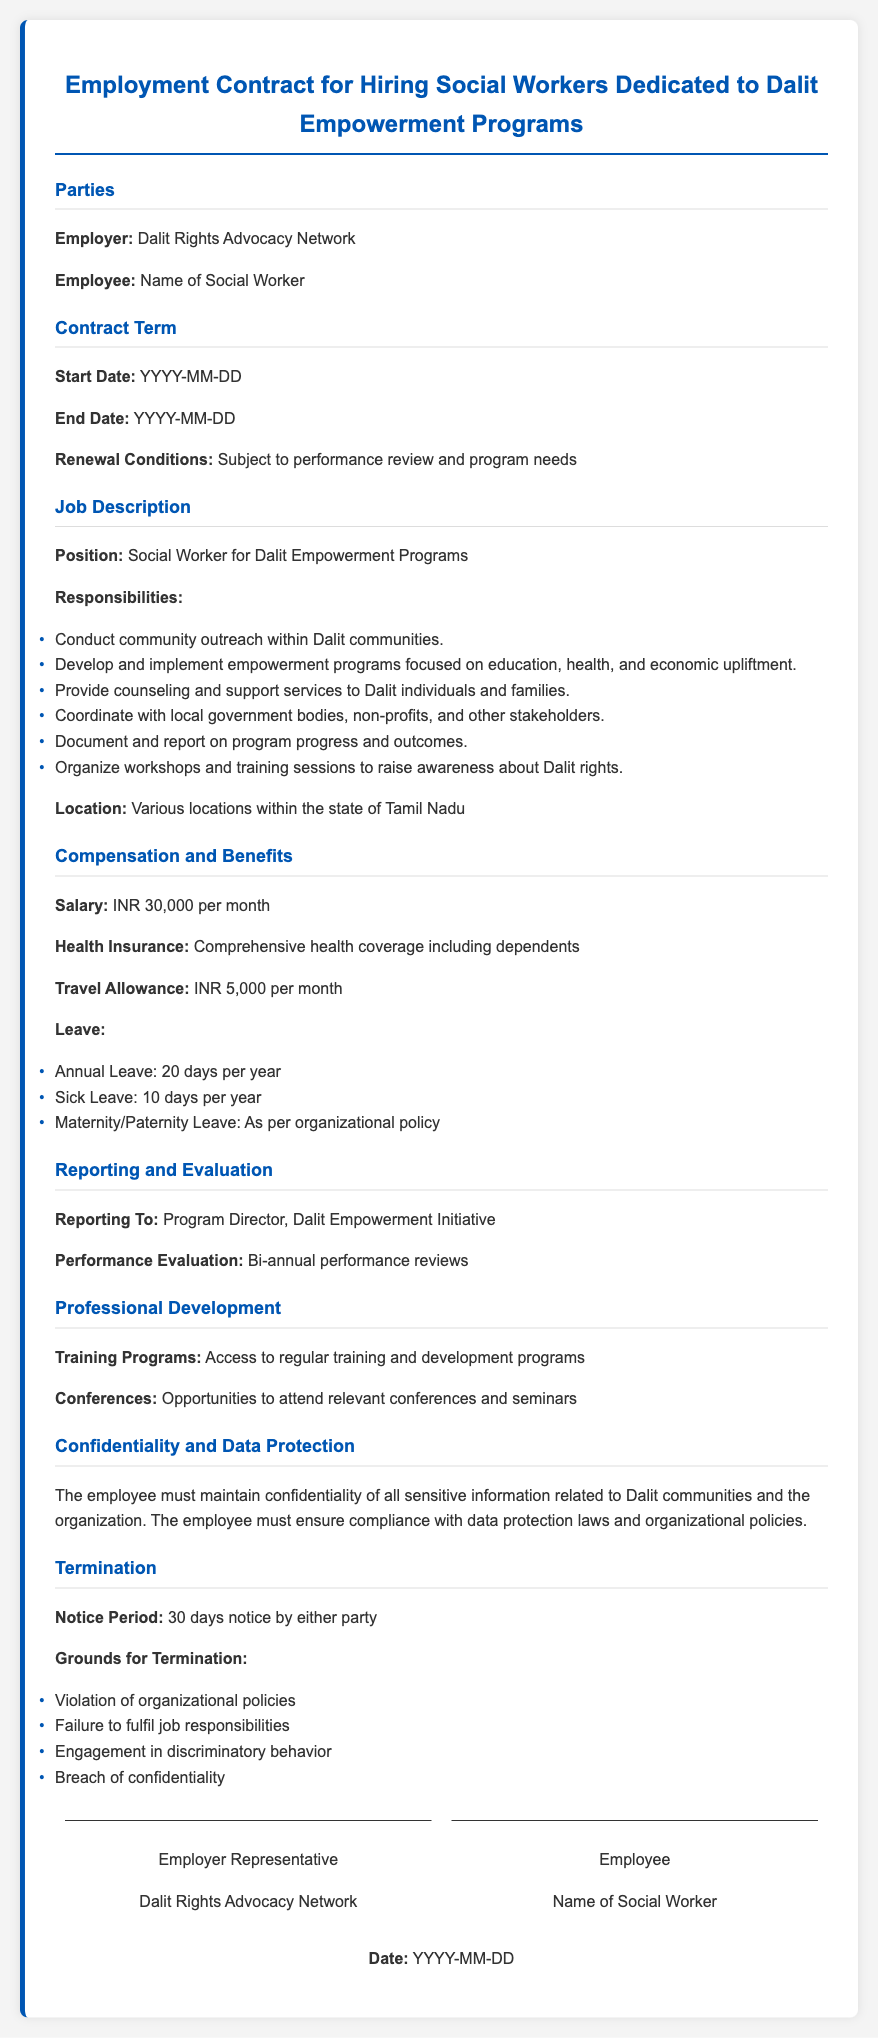what is the employer's name? The employer is specified in the document under the parties section.
Answer: Dalit Rights Advocacy Network what is the position title? The job title is mentioned under the job description section.
Answer: Social Worker for Dalit Empowerment Programs what is the monthly salary offered? The monthly salary is detailed in the compensation and benefits section.
Answer: INR 30,000 per month how many days of annual leave are provided? The number of annual leave days is stated in the leave section under compensation and benefits.
Answer: 20 days per year what is the notice period for termination? The notice period is indicated in the termination section of the document.
Answer: 30 days notice how many sick leave days are allowed? The allowed sick leave days are mentioned under the leave section in compensation and benefits.
Answer: 10 days per year who does the employee report to? The supervisor of the employee is indicated in the reporting and evaluation section.
Answer: Program Director, Dalit Empowerment Initiative what is required for job renewal? The conditions for job renewal are outlined in the contract term section.
Answer: Subject to performance review and program needs what constitutes grounds for termination? The grounds for termination are listed in the termination section of the contract.
Answer: Violation of organizational policies, Failure to fulfil job responsibilities, Engagement in discriminatory behavior, Breach of confidentiality 